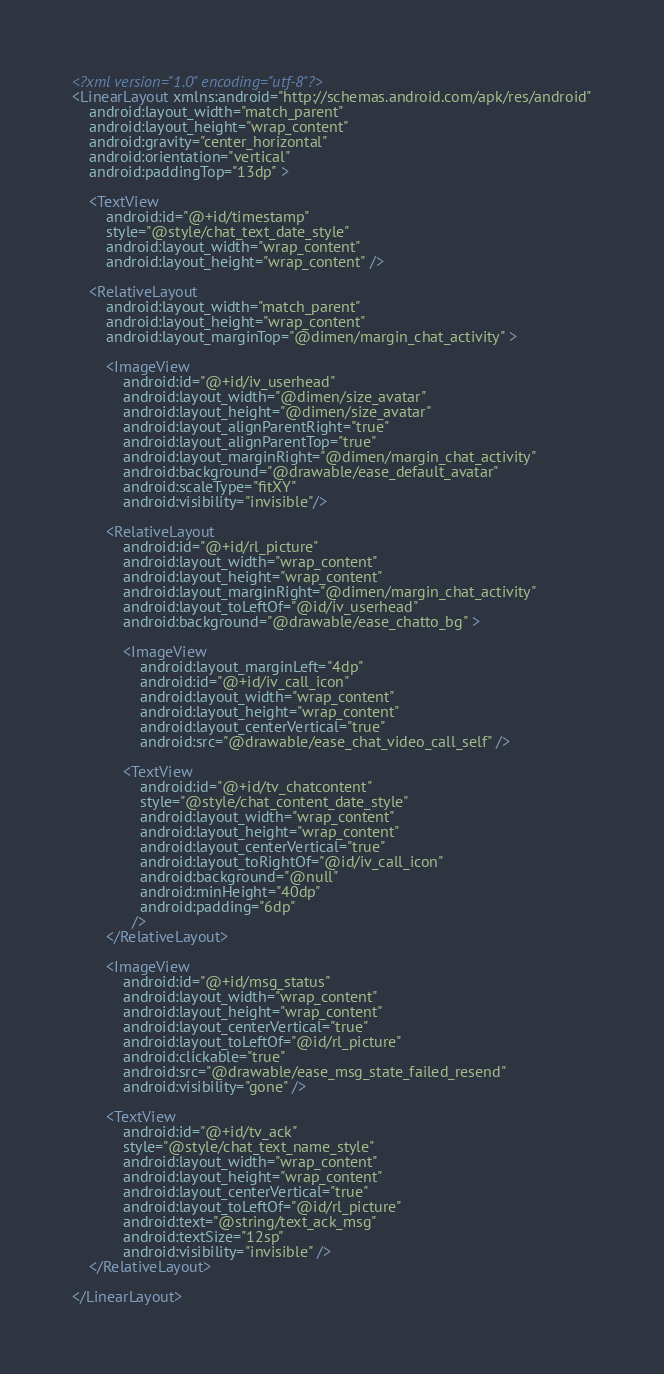<code> <loc_0><loc_0><loc_500><loc_500><_XML_><?xml version="1.0" encoding="utf-8"?>
<LinearLayout xmlns:android="http://schemas.android.com/apk/res/android"
    android:layout_width="match_parent"
    android:layout_height="wrap_content"
    android:gravity="center_horizontal"
    android:orientation="vertical"
    android:paddingTop="13dp" >

    <TextView
        android:id="@+id/timestamp"
        style="@style/chat_text_date_style"
        android:layout_width="wrap_content"
        android:layout_height="wrap_content" />

    <RelativeLayout
        android:layout_width="match_parent"
        android:layout_height="wrap_content"
        android:layout_marginTop="@dimen/margin_chat_activity" >

        <ImageView
            android:id="@+id/iv_userhead"
            android:layout_width="@dimen/size_avatar"
            android:layout_height="@dimen/size_avatar"
            android:layout_alignParentRight="true"
            android:layout_alignParentTop="true"
            android:layout_marginRight="@dimen/margin_chat_activity"
            android:background="@drawable/ease_default_avatar"
            android:scaleType="fitXY"
            android:visibility="invisible"/>

        <RelativeLayout
            android:id="@+id/rl_picture"
            android:layout_width="wrap_content"
            android:layout_height="wrap_content"
            android:layout_marginRight="@dimen/margin_chat_activity"
            android:layout_toLeftOf="@id/iv_userhead"
            android:background="@drawable/ease_chatto_bg" >

            <ImageView
                android:layout_marginLeft="4dp"
                android:id="@+id/iv_call_icon"
                android:layout_width="wrap_content"
                android:layout_height="wrap_content"
                android:layout_centerVertical="true"
                android:src="@drawable/ease_chat_video_call_self" />

            <TextView
                android:id="@+id/tv_chatcontent"
                style="@style/chat_content_date_style"
                android:layout_width="wrap_content"
                android:layout_height="wrap_content"
                android:layout_centerVertical="true"
                android:layout_toRightOf="@id/iv_call_icon"
                android:background="@null"
                android:minHeight="40dp"
                android:padding="6dp"
              />
        </RelativeLayout>

        <ImageView
            android:id="@+id/msg_status"
            android:layout_width="wrap_content"
            android:layout_height="wrap_content"
            android:layout_centerVertical="true"
            android:layout_toLeftOf="@id/rl_picture"
            android:clickable="true"
            android:src="@drawable/ease_msg_state_failed_resend"
            android:visibility="gone" />

        <TextView
            android:id="@+id/tv_ack"
            style="@style/chat_text_name_style"
            android:layout_width="wrap_content"
            android:layout_height="wrap_content"
            android:layout_centerVertical="true"
            android:layout_toLeftOf="@id/rl_picture"
            android:text="@string/text_ack_msg"
            android:textSize="12sp"
            android:visibility="invisible" />
    </RelativeLayout>

</LinearLayout></code> 